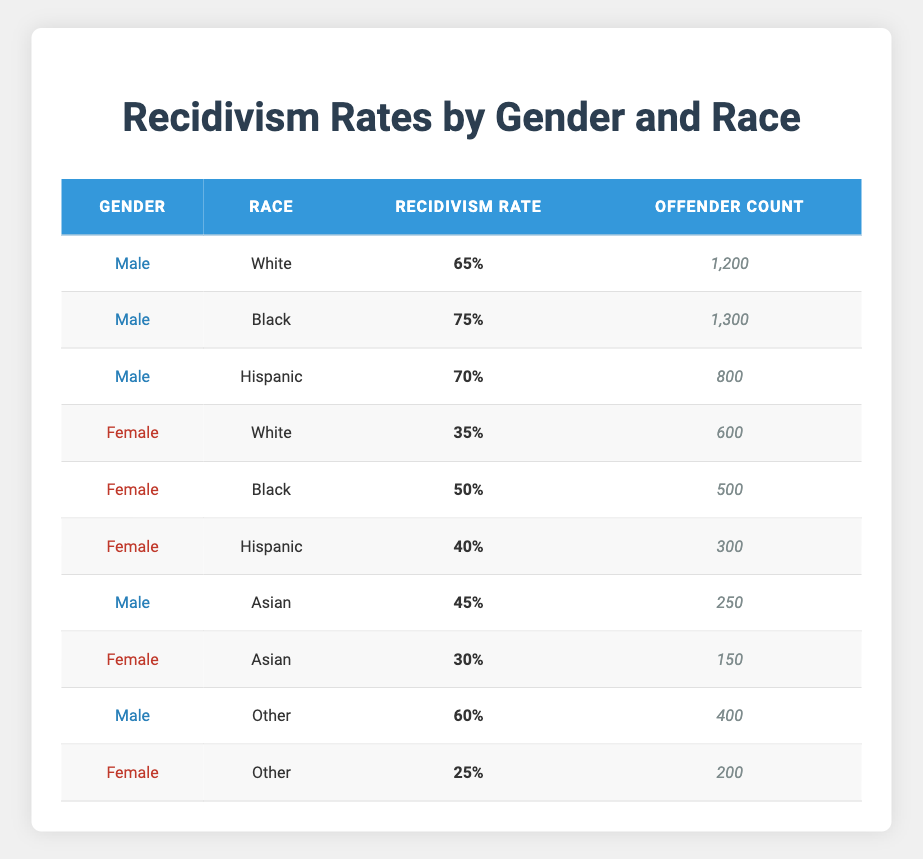What is the recidivism rate for Black females? The table shows the recidivism rate for females by race, and for Black females, the rate is listed as 50%.
Answer: 50% What is the offender count for Hispanic males? Checking the table for males of the Hispanic race, the offender count is recorded as 800.
Answer: 800 Which gender has a higher overall recidivism rate, males or females? To compare, we look at the average recidivism rates: Males: (65 + 75 + 70 + 45 + 60) / 5 = 61 and Females: (35 + 50 + 40 + 30 + 25) / 5 = 36. Thus, males have a higher average recidivism rate of 61 compared to females' 36.
Answer: Males Is the recidivism rate for White males higher than for Asian females? White males have a recidivism rate of 65%, whereas Asian females have a recidivism rate of 30%. Since 65% is greater than 30%, the statement is true.
Answer: Yes What is the difference in recidivism rates between Black males and Black females? The recidivism rate for Black males is 75% and for Black females is 50%. The difference is calculated as 75 - 50 = 25.
Answer: 25 What is the average recidivism rate for all Hispanic offenders? For Hispanic offenders, the recidivism rates are 70% for males and 40% for females. The average is calculated as (70 + 40) / 2 = 55.
Answer: 55 True or False: The recidivism rate for Female offenders of the Other race is higher than that for Male offenders of the same race. The table shows the female recidivism rate for Other as 25% and the male rate as 60%. Since 25% is less than 60%, the statement is false.
Answer: False What is the total offender count for Black males and Black females combined? The offender count for Black males is 1300 and for Black females is 500. Adding these gives 1300 + 500 = 1800.
Answer: 1800 Which race has the lowest recidivism rate among female offenders? Looking at the female recidivism rates: White 35%, Black 50%, Hispanic 40%, Asian 30%, Other 25%. The lowest rate is for Other at 25%.
Answer: Other 